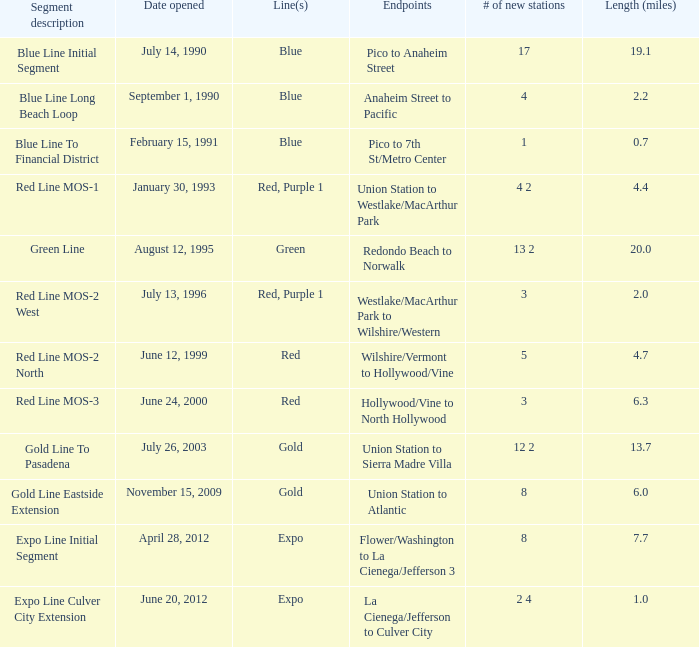0? 1.0. 